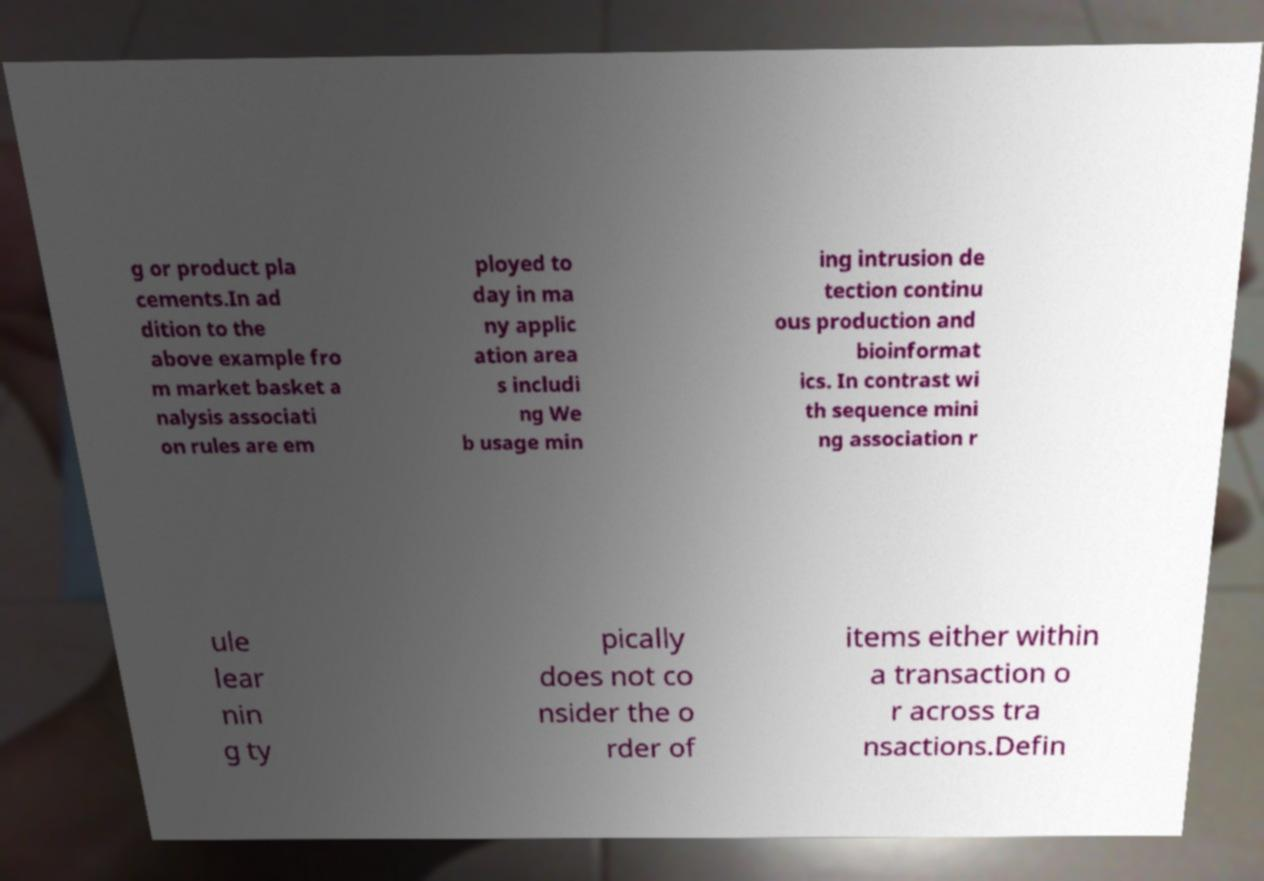Could you assist in decoding the text presented in this image and type it out clearly? g or product pla cements.In ad dition to the above example fro m market basket a nalysis associati on rules are em ployed to day in ma ny applic ation area s includi ng We b usage min ing intrusion de tection continu ous production and bioinformat ics. In contrast wi th sequence mini ng association r ule lear nin g ty pically does not co nsider the o rder of items either within a transaction o r across tra nsactions.Defin 